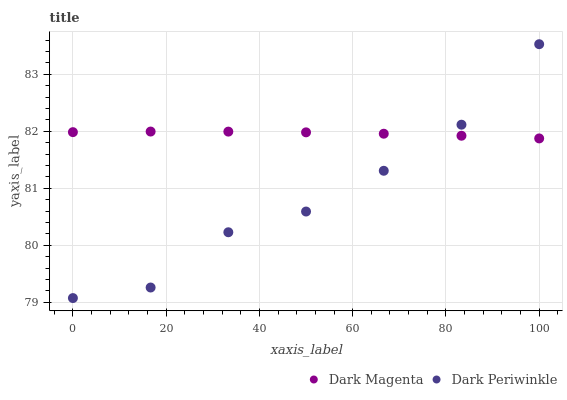Does Dark Periwinkle have the minimum area under the curve?
Answer yes or no. Yes. Does Dark Magenta have the maximum area under the curve?
Answer yes or no. Yes. Does Dark Periwinkle have the maximum area under the curve?
Answer yes or no. No. Is Dark Magenta the smoothest?
Answer yes or no. Yes. Is Dark Periwinkle the roughest?
Answer yes or no. Yes. Is Dark Periwinkle the smoothest?
Answer yes or no. No. Does Dark Periwinkle have the lowest value?
Answer yes or no. Yes. Does Dark Periwinkle have the highest value?
Answer yes or no. Yes. Does Dark Magenta intersect Dark Periwinkle?
Answer yes or no. Yes. Is Dark Magenta less than Dark Periwinkle?
Answer yes or no. No. Is Dark Magenta greater than Dark Periwinkle?
Answer yes or no. No. 